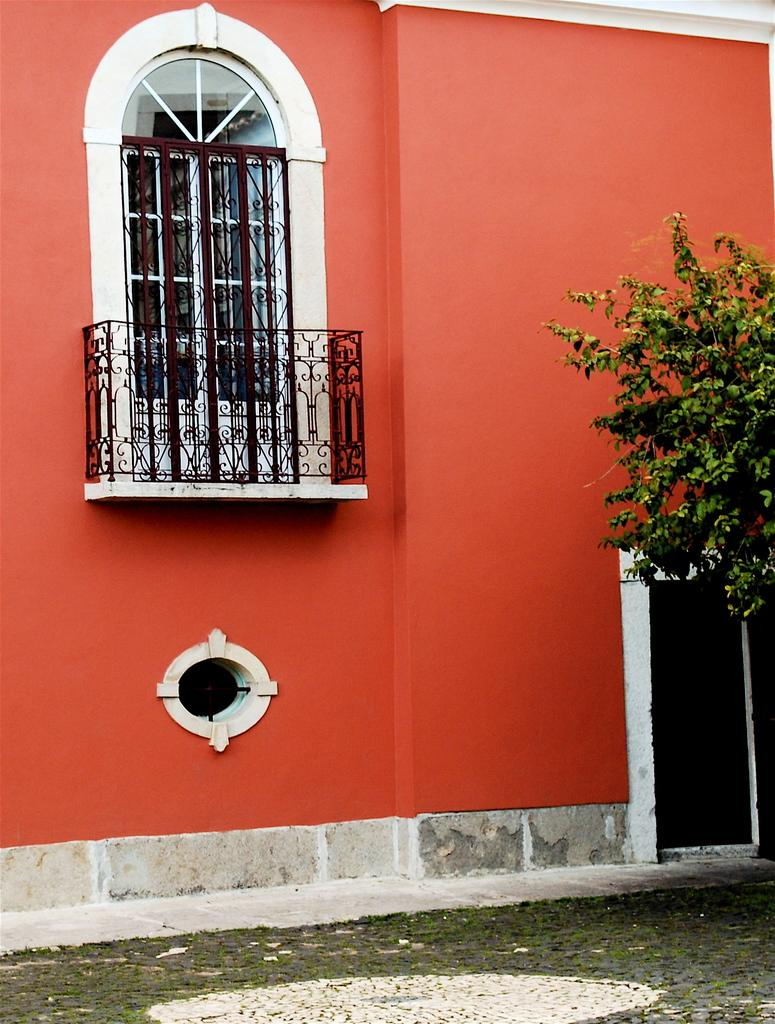What color is the wall in the image? The wall in the image is orange-colored. What architectural feature can be seen in the image? There is a window in the image. What type of vegetation is present in the image? Green-colored leaves and grass are visible in the image. What type of honey can be seen dripping from the window in the image? There is no honey present in the image; it only features an orange-colored wall, a window, and green-colored leaves and grass. 